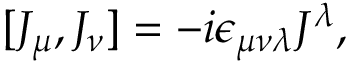<formula> <loc_0><loc_0><loc_500><loc_500>[ J _ { \mu } , J _ { \nu } ] = - i \epsilon _ { \mu \nu \lambda } J ^ { \lambda } ,</formula> 